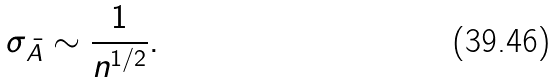<formula> <loc_0><loc_0><loc_500><loc_500>\sigma _ { \bar { A } } \sim \frac { 1 } { n ^ { 1 / 2 } } .</formula> 